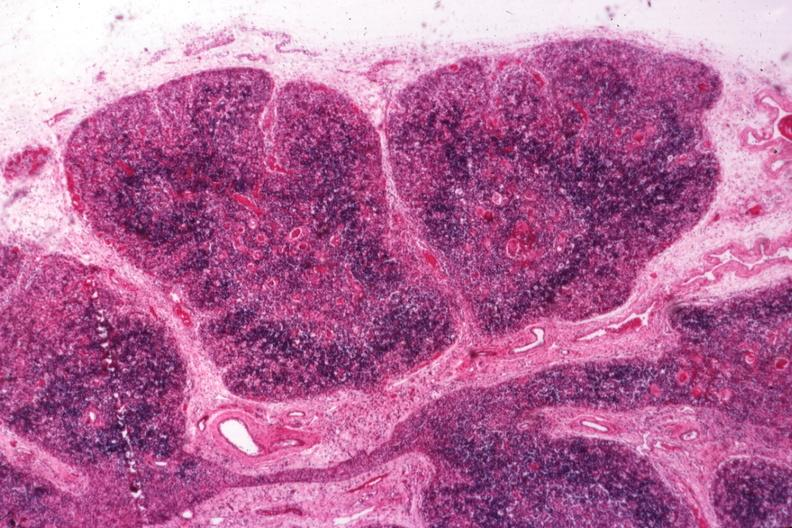what does this image show?
Answer the question using a single word or phrase. Typical atrophy associated with infection in newborn 